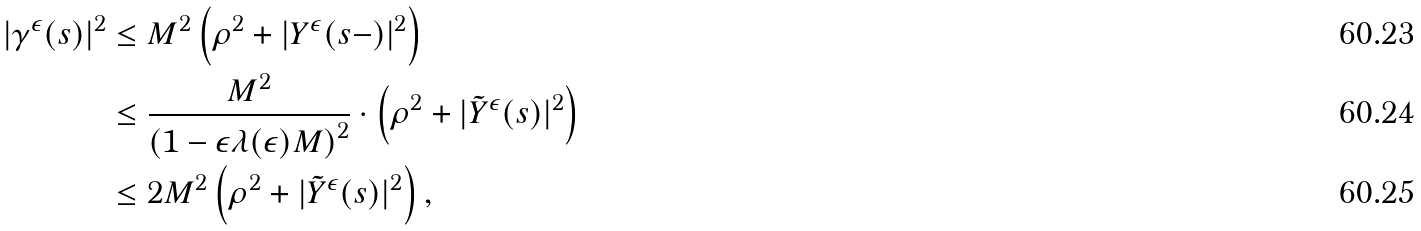Convert formula to latex. <formula><loc_0><loc_0><loc_500><loc_500>| \gamma ^ { \epsilon } ( s ) | ^ { 2 } & \leq M ^ { 2 } \left ( \rho ^ { 2 } + | Y ^ { \epsilon } ( s - ) | ^ { 2 } \right ) \\ & \leq \frac { M ^ { 2 } } { \left ( 1 - \epsilon \lambda ( \epsilon ) M \right ) ^ { 2 } } \cdot \left ( \rho ^ { 2 } + | \tilde { Y } ^ { \epsilon } ( s ) | ^ { 2 } \right ) \\ & \leq 2 M ^ { 2 } \left ( \rho ^ { 2 } + | \tilde { Y } ^ { \epsilon } ( s ) | ^ { 2 } \right ) ,</formula> 